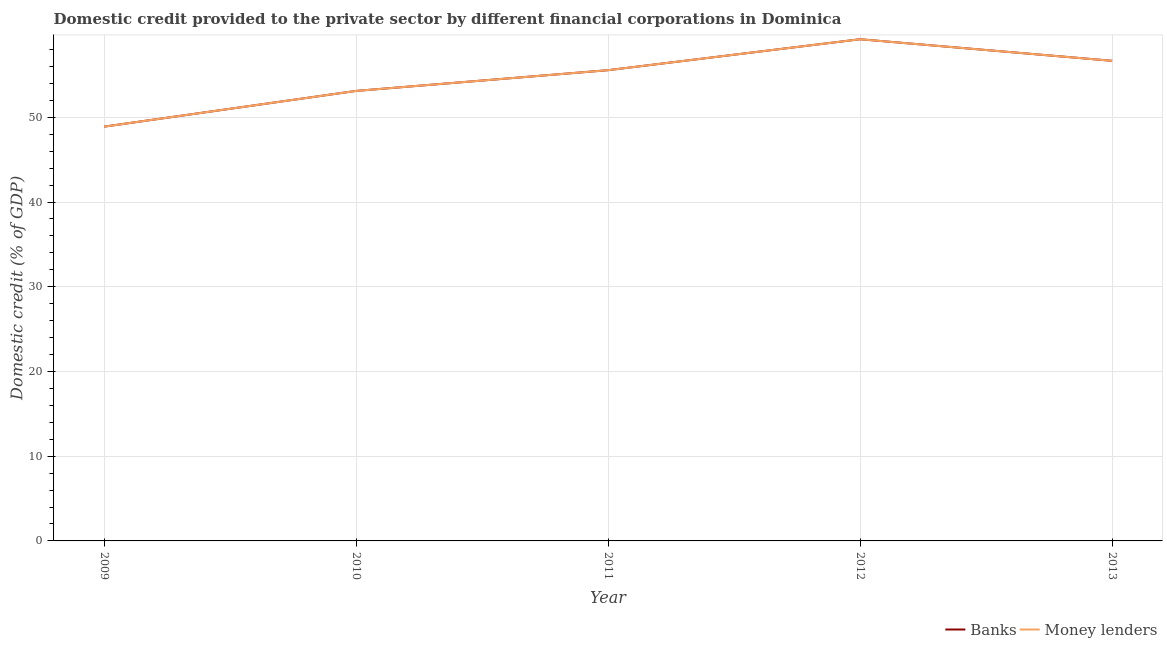How many different coloured lines are there?
Ensure brevity in your answer.  2. Does the line corresponding to domestic credit provided by banks intersect with the line corresponding to domestic credit provided by money lenders?
Ensure brevity in your answer.  Yes. What is the domestic credit provided by money lenders in 2009?
Ensure brevity in your answer.  48.9. Across all years, what is the maximum domestic credit provided by money lenders?
Offer a very short reply. 59.21. Across all years, what is the minimum domestic credit provided by money lenders?
Offer a very short reply. 48.9. In which year was the domestic credit provided by banks minimum?
Offer a very short reply. 2009. What is the total domestic credit provided by banks in the graph?
Your answer should be very brief. 273.46. What is the difference between the domestic credit provided by banks in 2009 and that in 2013?
Give a very brief answer. -7.77. What is the difference between the domestic credit provided by money lenders in 2009 and the domestic credit provided by banks in 2010?
Give a very brief answer. -4.22. What is the average domestic credit provided by banks per year?
Provide a short and direct response. 54.69. In the year 2011, what is the difference between the domestic credit provided by banks and domestic credit provided by money lenders?
Ensure brevity in your answer.  0. What is the ratio of the domestic credit provided by banks in 2009 to that in 2013?
Keep it short and to the point. 0.86. Is the domestic credit provided by money lenders in 2009 less than that in 2013?
Offer a terse response. Yes. What is the difference between the highest and the second highest domestic credit provided by money lenders?
Keep it short and to the point. 2.55. What is the difference between the highest and the lowest domestic credit provided by money lenders?
Your answer should be compact. 10.32. Does the domestic credit provided by banks monotonically increase over the years?
Your response must be concise. No. Are the values on the major ticks of Y-axis written in scientific E-notation?
Keep it short and to the point. No. Does the graph contain any zero values?
Your answer should be very brief. No. Where does the legend appear in the graph?
Offer a very short reply. Bottom right. How many legend labels are there?
Keep it short and to the point. 2. What is the title of the graph?
Make the answer very short. Domestic credit provided to the private sector by different financial corporations in Dominica. Does "Depositors" appear as one of the legend labels in the graph?
Your answer should be compact. No. What is the label or title of the Y-axis?
Provide a succinct answer. Domestic credit (% of GDP). What is the Domestic credit (% of GDP) of Banks in 2009?
Provide a short and direct response. 48.9. What is the Domestic credit (% of GDP) in Money lenders in 2009?
Offer a very short reply. 48.9. What is the Domestic credit (% of GDP) of Banks in 2010?
Your response must be concise. 53.12. What is the Domestic credit (% of GDP) of Money lenders in 2010?
Your answer should be compact. 53.12. What is the Domestic credit (% of GDP) of Banks in 2011?
Keep it short and to the point. 55.56. What is the Domestic credit (% of GDP) of Money lenders in 2011?
Give a very brief answer. 55.56. What is the Domestic credit (% of GDP) of Banks in 2012?
Offer a terse response. 59.21. What is the Domestic credit (% of GDP) in Money lenders in 2012?
Offer a very short reply. 59.21. What is the Domestic credit (% of GDP) in Banks in 2013?
Keep it short and to the point. 56.67. What is the Domestic credit (% of GDP) of Money lenders in 2013?
Your answer should be very brief. 56.67. Across all years, what is the maximum Domestic credit (% of GDP) in Banks?
Offer a very short reply. 59.21. Across all years, what is the maximum Domestic credit (% of GDP) of Money lenders?
Make the answer very short. 59.21. Across all years, what is the minimum Domestic credit (% of GDP) of Banks?
Your answer should be compact. 48.9. Across all years, what is the minimum Domestic credit (% of GDP) in Money lenders?
Your answer should be very brief. 48.9. What is the total Domestic credit (% of GDP) in Banks in the graph?
Give a very brief answer. 273.46. What is the total Domestic credit (% of GDP) of Money lenders in the graph?
Keep it short and to the point. 273.46. What is the difference between the Domestic credit (% of GDP) of Banks in 2009 and that in 2010?
Give a very brief answer. -4.22. What is the difference between the Domestic credit (% of GDP) of Money lenders in 2009 and that in 2010?
Provide a short and direct response. -4.22. What is the difference between the Domestic credit (% of GDP) in Banks in 2009 and that in 2011?
Offer a terse response. -6.67. What is the difference between the Domestic credit (% of GDP) in Money lenders in 2009 and that in 2011?
Ensure brevity in your answer.  -6.67. What is the difference between the Domestic credit (% of GDP) in Banks in 2009 and that in 2012?
Ensure brevity in your answer.  -10.32. What is the difference between the Domestic credit (% of GDP) of Money lenders in 2009 and that in 2012?
Make the answer very short. -10.32. What is the difference between the Domestic credit (% of GDP) of Banks in 2009 and that in 2013?
Offer a terse response. -7.77. What is the difference between the Domestic credit (% of GDP) of Money lenders in 2009 and that in 2013?
Provide a succinct answer. -7.77. What is the difference between the Domestic credit (% of GDP) of Banks in 2010 and that in 2011?
Ensure brevity in your answer.  -2.45. What is the difference between the Domestic credit (% of GDP) in Money lenders in 2010 and that in 2011?
Give a very brief answer. -2.45. What is the difference between the Domestic credit (% of GDP) of Banks in 2010 and that in 2012?
Your answer should be compact. -6.1. What is the difference between the Domestic credit (% of GDP) of Money lenders in 2010 and that in 2012?
Your answer should be very brief. -6.1. What is the difference between the Domestic credit (% of GDP) of Banks in 2010 and that in 2013?
Ensure brevity in your answer.  -3.55. What is the difference between the Domestic credit (% of GDP) of Money lenders in 2010 and that in 2013?
Give a very brief answer. -3.55. What is the difference between the Domestic credit (% of GDP) of Banks in 2011 and that in 2012?
Your answer should be very brief. -3.65. What is the difference between the Domestic credit (% of GDP) of Money lenders in 2011 and that in 2012?
Make the answer very short. -3.65. What is the difference between the Domestic credit (% of GDP) in Banks in 2011 and that in 2013?
Offer a terse response. -1.1. What is the difference between the Domestic credit (% of GDP) in Money lenders in 2011 and that in 2013?
Offer a very short reply. -1.1. What is the difference between the Domestic credit (% of GDP) of Banks in 2012 and that in 2013?
Give a very brief answer. 2.55. What is the difference between the Domestic credit (% of GDP) in Money lenders in 2012 and that in 2013?
Your response must be concise. 2.55. What is the difference between the Domestic credit (% of GDP) of Banks in 2009 and the Domestic credit (% of GDP) of Money lenders in 2010?
Provide a succinct answer. -4.22. What is the difference between the Domestic credit (% of GDP) in Banks in 2009 and the Domestic credit (% of GDP) in Money lenders in 2011?
Keep it short and to the point. -6.67. What is the difference between the Domestic credit (% of GDP) in Banks in 2009 and the Domestic credit (% of GDP) in Money lenders in 2012?
Give a very brief answer. -10.32. What is the difference between the Domestic credit (% of GDP) of Banks in 2009 and the Domestic credit (% of GDP) of Money lenders in 2013?
Keep it short and to the point. -7.77. What is the difference between the Domestic credit (% of GDP) in Banks in 2010 and the Domestic credit (% of GDP) in Money lenders in 2011?
Provide a short and direct response. -2.45. What is the difference between the Domestic credit (% of GDP) of Banks in 2010 and the Domestic credit (% of GDP) of Money lenders in 2012?
Give a very brief answer. -6.1. What is the difference between the Domestic credit (% of GDP) in Banks in 2010 and the Domestic credit (% of GDP) in Money lenders in 2013?
Keep it short and to the point. -3.55. What is the difference between the Domestic credit (% of GDP) of Banks in 2011 and the Domestic credit (% of GDP) of Money lenders in 2012?
Your answer should be very brief. -3.65. What is the difference between the Domestic credit (% of GDP) of Banks in 2011 and the Domestic credit (% of GDP) of Money lenders in 2013?
Your response must be concise. -1.1. What is the difference between the Domestic credit (% of GDP) in Banks in 2012 and the Domestic credit (% of GDP) in Money lenders in 2013?
Ensure brevity in your answer.  2.55. What is the average Domestic credit (% of GDP) in Banks per year?
Provide a short and direct response. 54.69. What is the average Domestic credit (% of GDP) in Money lenders per year?
Your response must be concise. 54.69. In the year 2011, what is the difference between the Domestic credit (% of GDP) in Banks and Domestic credit (% of GDP) in Money lenders?
Offer a very short reply. 0. What is the ratio of the Domestic credit (% of GDP) in Banks in 2009 to that in 2010?
Provide a succinct answer. 0.92. What is the ratio of the Domestic credit (% of GDP) in Money lenders in 2009 to that in 2010?
Ensure brevity in your answer.  0.92. What is the ratio of the Domestic credit (% of GDP) of Banks in 2009 to that in 2011?
Give a very brief answer. 0.88. What is the ratio of the Domestic credit (% of GDP) in Banks in 2009 to that in 2012?
Provide a succinct answer. 0.83. What is the ratio of the Domestic credit (% of GDP) in Money lenders in 2009 to that in 2012?
Offer a terse response. 0.83. What is the ratio of the Domestic credit (% of GDP) of Banks in 2009 to that in 2013?
Provide a succinct answer. 0.86. What is the ratio of the Domestic credit (% of GDP) in Money lenders in 2009 to that in 2013?
Provide a short and direct response. 0.86. What is the ratio of the Domestic credit (% of GDP) of Banks in 2010 to that in 2011?
Keep it short and to the point. 0.96. What is the ratio of the Domestic credit (% of GDP) in Money lenders in 2010 to that in 2011?
Provide a short and direct response. 0.96. What is the ratio of the Domestic credit (% of GDP) of Banks in 2010 to that in 2012?
Offer a terse response. 0.9. What is the ratio of the Domestic credit (% of GDP) of Money lenders in 2010 to that in 2012?
Provide a short and direct response. 0.9. What is the ratio of the Domestic credit (% of GDP) in Banks in 2010 to that in 2013?
Keep it short and to the point. 0.94. What is the ratio of the Domestic credit (% of GDP) in Money lenders in 2010 to that in 2013?
Ensure brevity in your answer.  0.94. What is the ratio of the Domestic credit (% of GDP) in Banks in 2011 to that in 2012?
Make the answer very short. 0.94. What is the ratio of the Domestic credit (% of GDP) of Money lenders in 2011 to that in 2012?
Give a very brief answer. 0.94. What is the ratio of the Domestic credit (% of GDP) in Banks in 2011 to that in 2013?
Your answer should be very brief. 0.98. What is the ratio of the Domestic credit (% of GDP) of Money lenders in 2011 to that in 2013?
Your response must be concise. 0.98. What is the ratio of the Domestic credit (% of GDP) in Banks in 2012 to that in 2013?
Keep it short and to the point. 1.04. What is the ratio of the Domestic credit (% of GDP) in Money lenders in 2012 to that in 2013?
Offer a very short reply. 1.04. What is the difference between the highest and the second highest Domestic credit (% of GDP) of Banks?
Give a very brief answer. 2.55. What is the difference between the highest and the second highest Domestic credit (% of GDP) of Money lenders?
Keep it short and to the point. 2.55. What is the difference between the highest and the lowest Domestic credit (% of GDP) of Banks?
Offer a terse response. 10.32. What is the difference between the highest and the lowest Domestic credit (% of GDP) of Money lenders?
Your response must be concise. 10.32. 